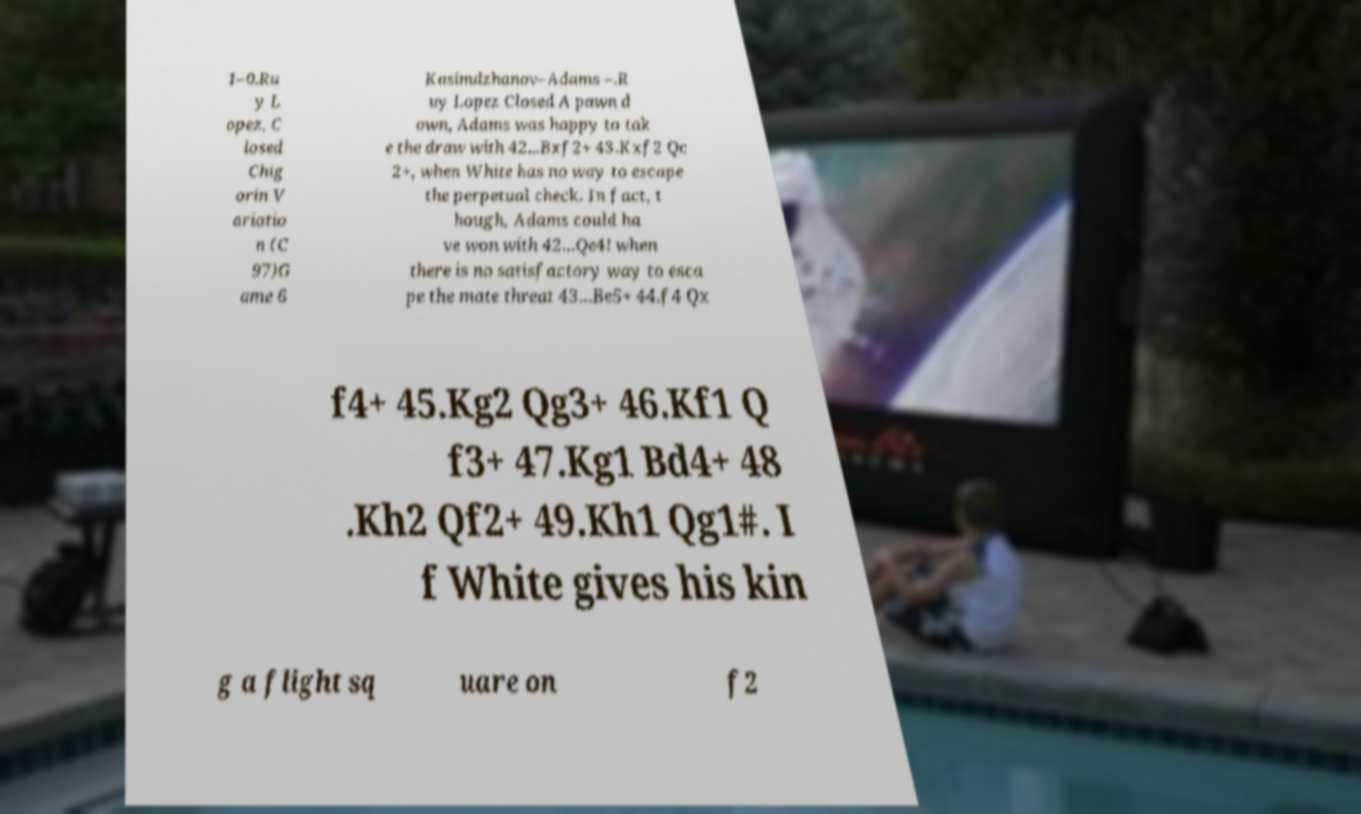I need the written content from this picture converted into text. Can you do that? 1–0.Ru y L opez, C losed Chig orin V ariatio n (C 97)G ame 6 Kasimdzhanov–Adams –.R uy Lopez Closed A pawn d own, Adams was happy to tak e the draw with 42...Bxf2+ 43.Kxf2 Qc 2+, when White has no way to escape the perpetual check. In fact, t hough, Adams could ha ve won with 42...Qe4! when there is no satisfactory way to esca pe the mate threat 43...Be5+ 44.f4 Qx f4+ 45.Kg2 Qg3+ 46.Kf1 Q f3+ 47.Kg1 Bd4+ 48 .Kh2 Qf2+ 49.Kh1 Qg1#. I f White gives his kin g a flight sq uare on f2 